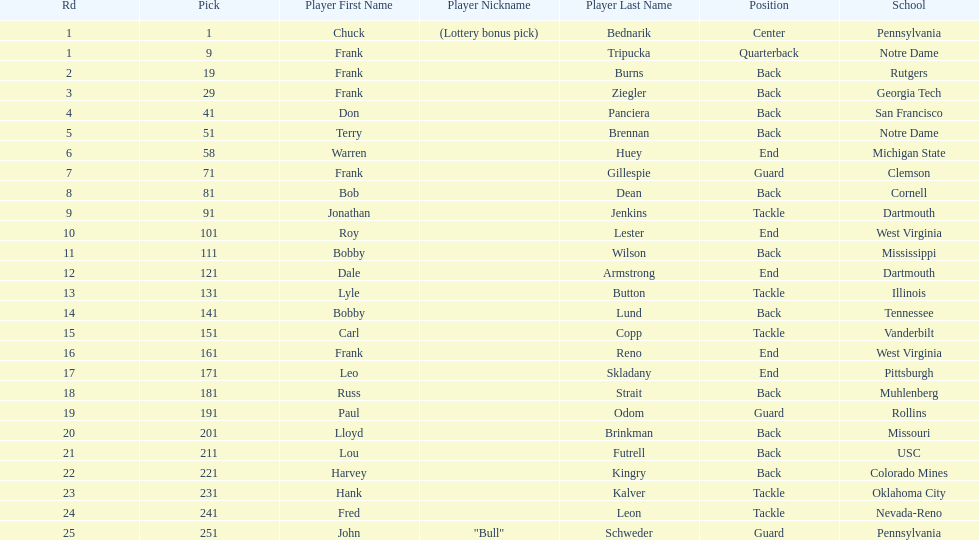How many players were from notre dame? 2. 